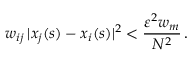Convert formula to latex. <formula><loc_0><loc_0><loc_500><loc_500>w _ { i j } \, | x _ { j } ( s ) - x _ { i } ( s ) | ^ { 2 } < \frac { \varepsilon ^ { 2 } w _ { m } } { N ^ { 2 } } \, .</formula> 